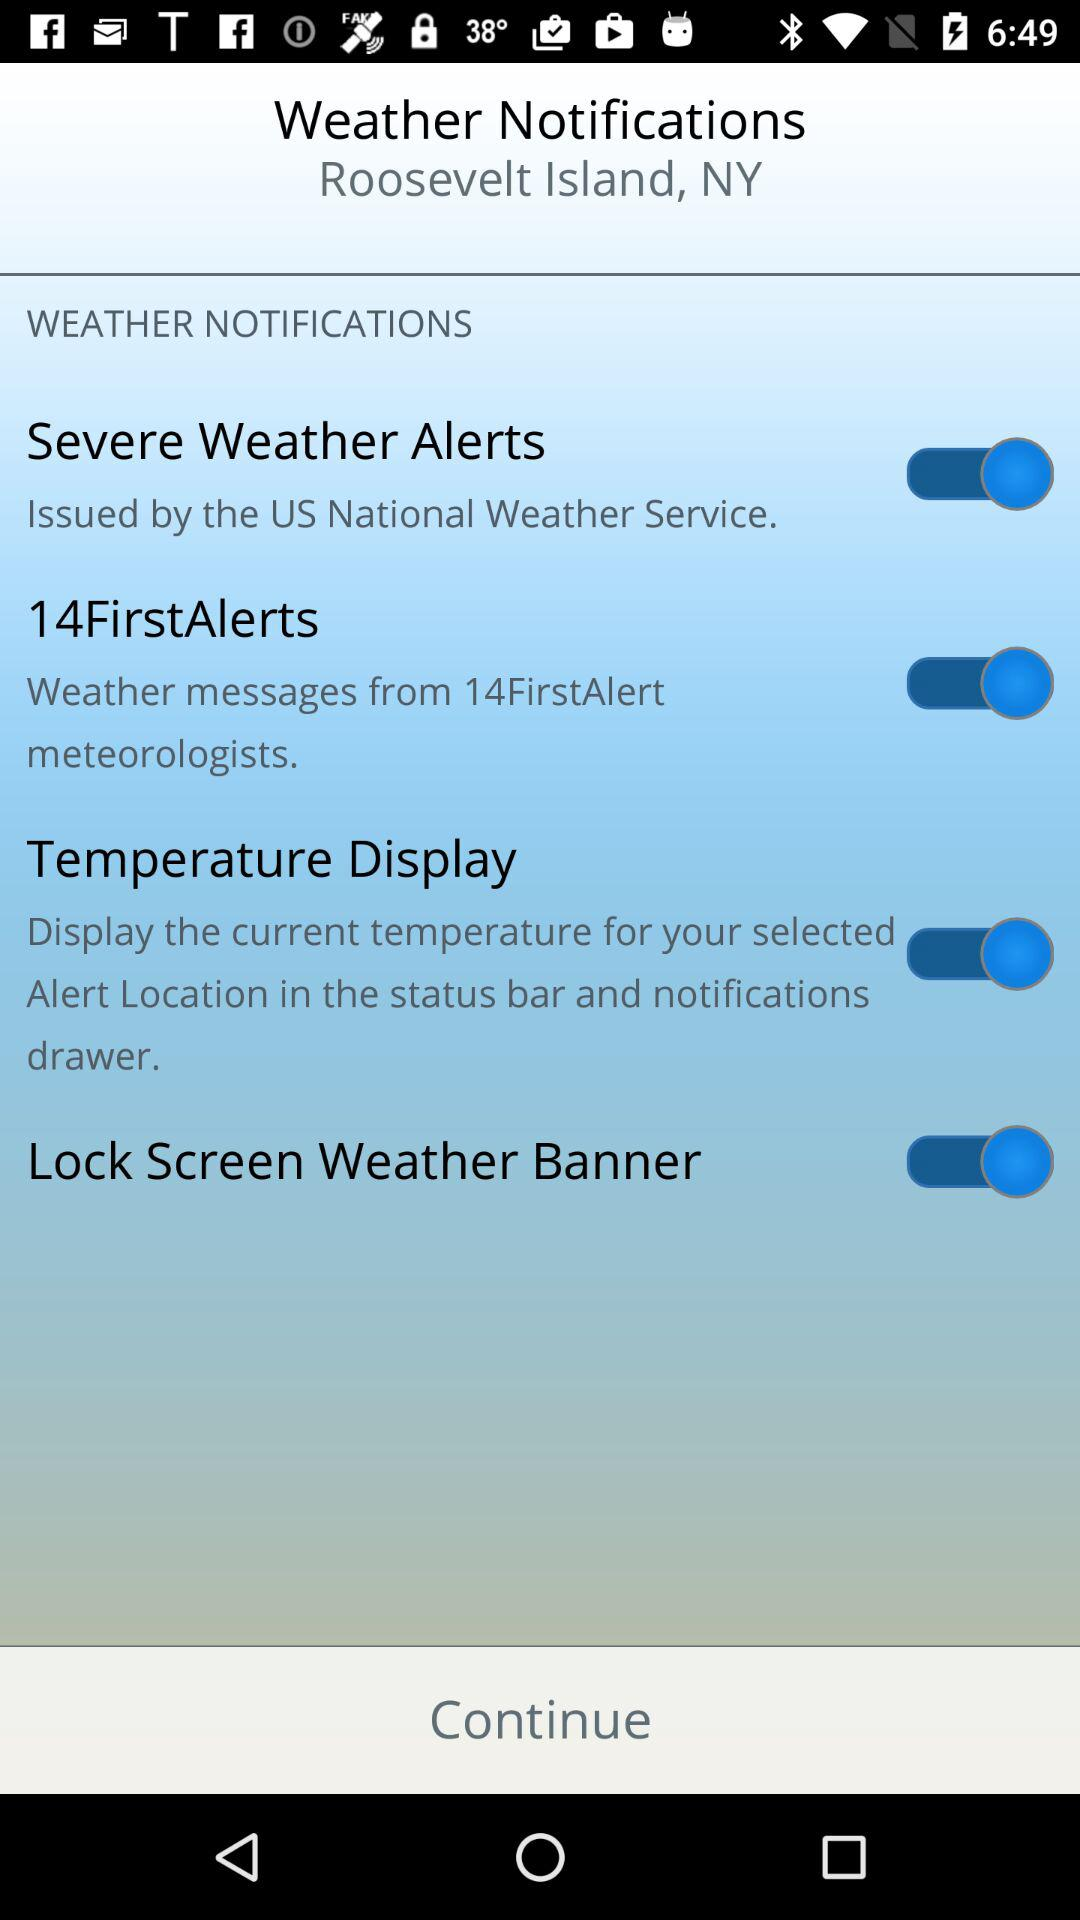What is the status of the "14FirstAlerts"? The status is "on". 